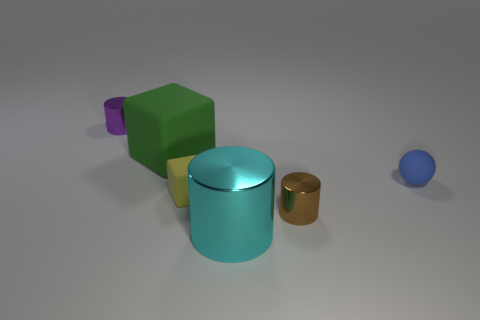Subtract all small metallic cylinders. How many cylinders are left? 1 Add 2 small blue matte spheres. How many objects exist? 8 Subtract all cubes. How many objects are left? 4 Add 5 large green things. How many large green things are left? 6 Add 6 brown cylinders. How many brown cylinders exist? 7 Subtract 0 yellow cylinders. How many objects are left? 6 Subtract all small purple blocks. Subtract all large green rubber things. How many objects are left? 5 